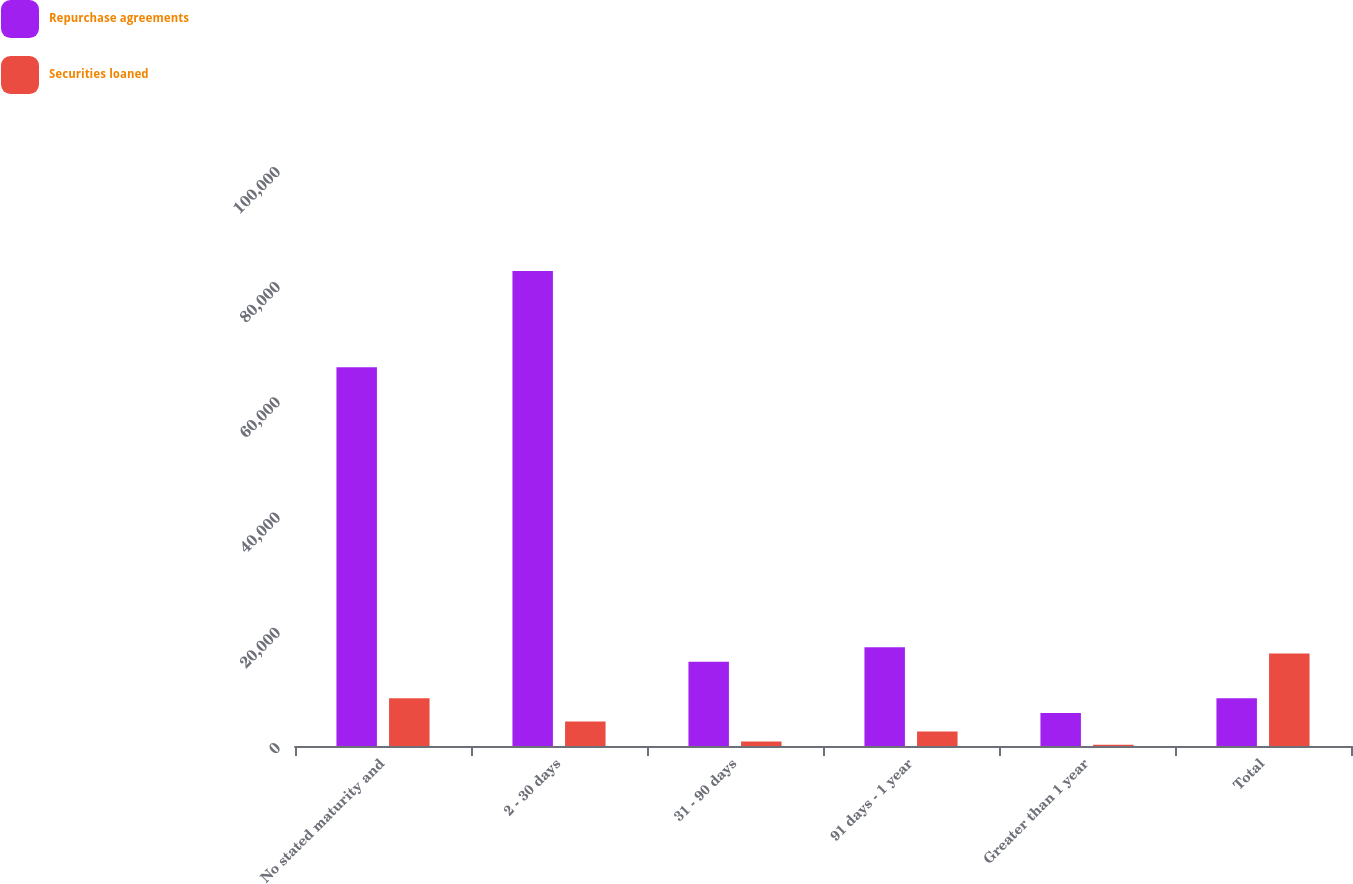<chart> <loc_0><loc_0><loc_500><loc_500><stacked_bar_chart><ecel><fcel>No stated maturity and<fcel>2 - 30 days<fcel>31 - 90 days<fcel>91 days - 1 year<fcel>Greater than 1 year<fcel>Total<nl><fcel>Repurchase agreements<fcel>65764<fcel>82482<fcel>14636<fcel>17137<fcel>5730<fcel>8300<nl><fcel>Securities loaned<fcel>8300<fcel>4273<fcel>774<fcel>2503<fcel>229<fcel>16079<nl></chart> 